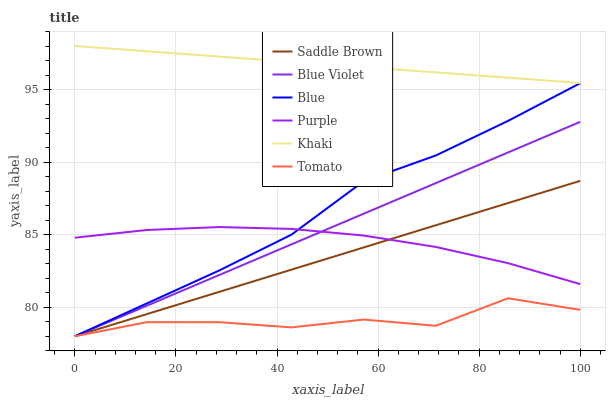Does Tomato have the minimum area under the curve?
Answer yes or no. Yes. Does Khaki have the maximum area under the curve?
Answer yes or no. Yes. Does Khaki have the minimum area under the curve?
Answer yes or no. No. Does Tomato have the maximum area under the curve?
Answer yes or no. No. Is Saddle Brown the smoothest?
Answer yes or no. Yes. Is Tomato the roughest?
Answer yes or no. Yes. Is Khaki the smoothest?
Answer yes or no. No. Is Khaki the roughest?
Answer yes or no. No. Does Blue have the lowest value?
Answer yes or no. Yes. Does Khaki have the lowest value?
Answer yes or no. No. Does Khaki have the highest value?
Answer yes or no. Yes. Does Tomato have the highest value?
Answer yes or no. No. Is Blue Violet less than Khaki?
Answer yes or no. Yes. Is Khaki greater than Blue Violet?
Answer yes or no. Yes. Does Blue intersect Saddle Brown?
Answer yes or no. Yes. Is Blue less than Saddle Brown?
Answer yes or no. No. Is Blue greater than Saddle Brown?
Answer yes or no. No. Does Blue Violet intersect Khaki?
Answer yes or no. No. 